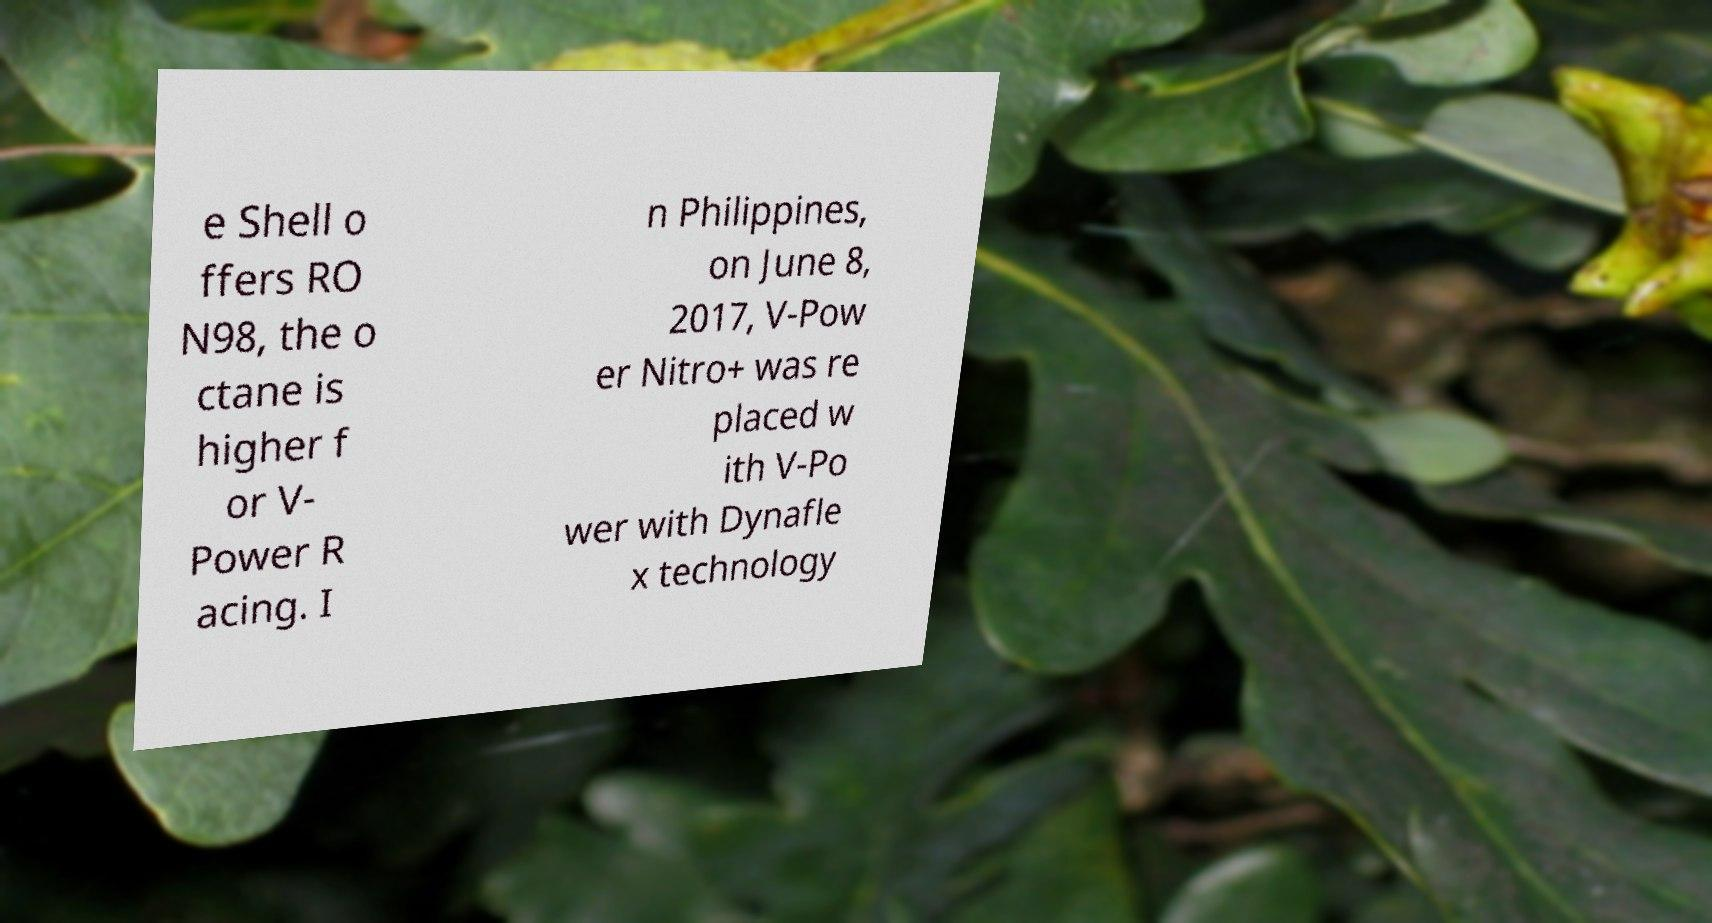What messages or text are displayed in this image? I need them in a readable, typed format. e Shell o ffers RO N98, the o ctane is higher f or V- Power R acing. I n Philippines, on June 8, 2017, V-Pow er Nitro+ was re placed w ith V-Po wer with Dynafle x technology 